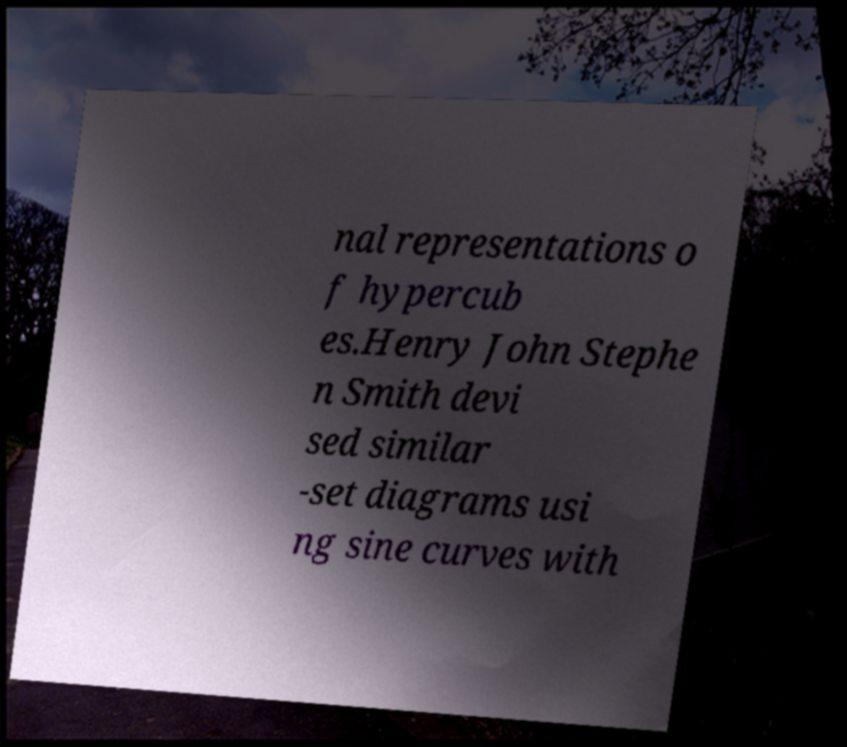Could you assist in decoding the text presented in this image and type it out clearly? nal representations o f hypercub es.Henry John Stephe n Smith devi sed similar -set diagrams usi ng sine curves with 